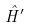<formula> <loc_0><loc_0><loc_500><loc_500>\hat { H } ^ { \prime }</formula> 